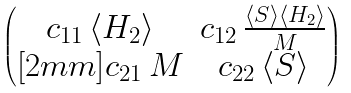Convert formula to latex. <formula><loc_0><loc_0><loc_500><loc_500>\begin{pmatrix} c _ { 1 1 } \, \langle H _ { 2 } \rangle & c _ { 1 2 } \, \frac { \langle S \rangle \langle H _ { 2 } \rangle } { M } \\ [ 2 m m ] c _ { 2 1 } \, M & c _ { 2 2 } \, \langle S \rangle \end{pmatrix}</formula> 